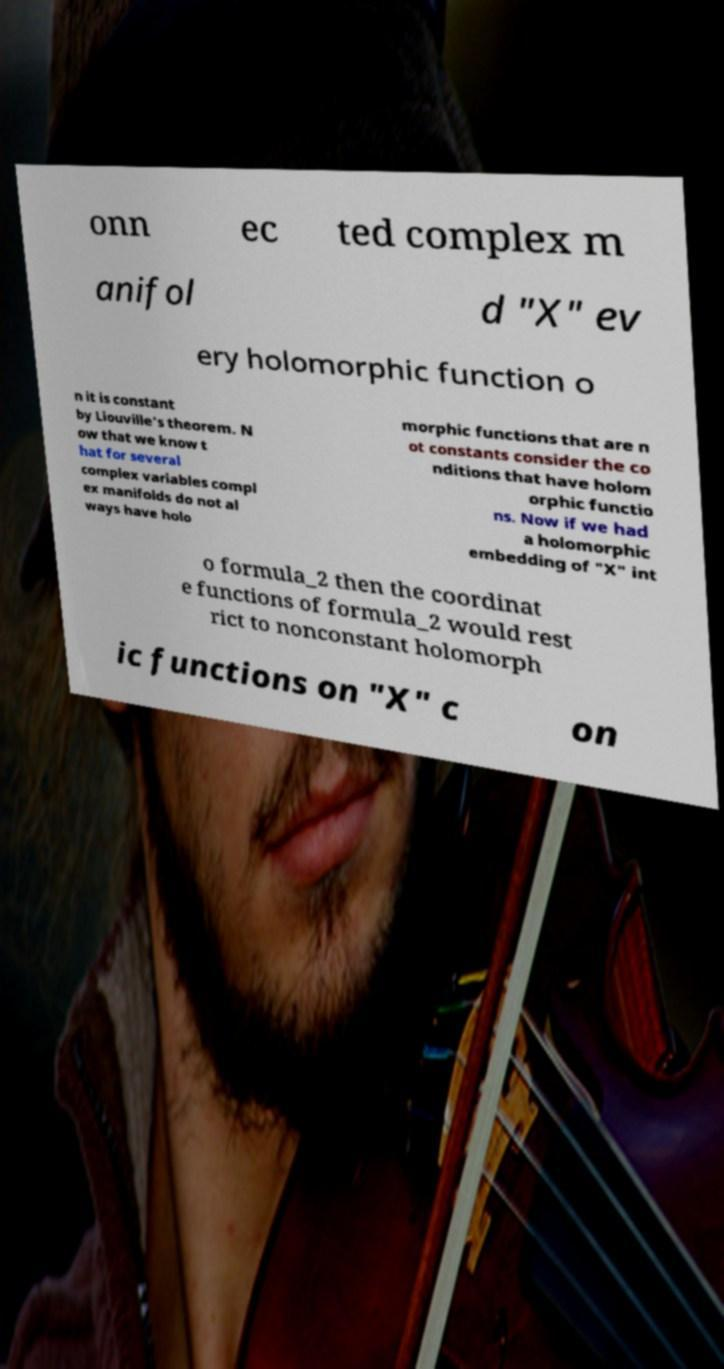Please read and relay the text visible in this image. What does it say? onn ec ted complex m anifol d "X" ev ery holomorphic function o n it is constant by Liouville's theorem. N ow that we know t hat for several complex variables compl ex manifolds do not al ways have holo morphic functions that are n ot constants consider the co nditions that have holom orphic functio ns. Now if we had a holomorphic embedding of "X" int o formula_2 then the coordinat e functions of formula_2 would rest rict to nonconstant holomorph ic functions on "X" c on 